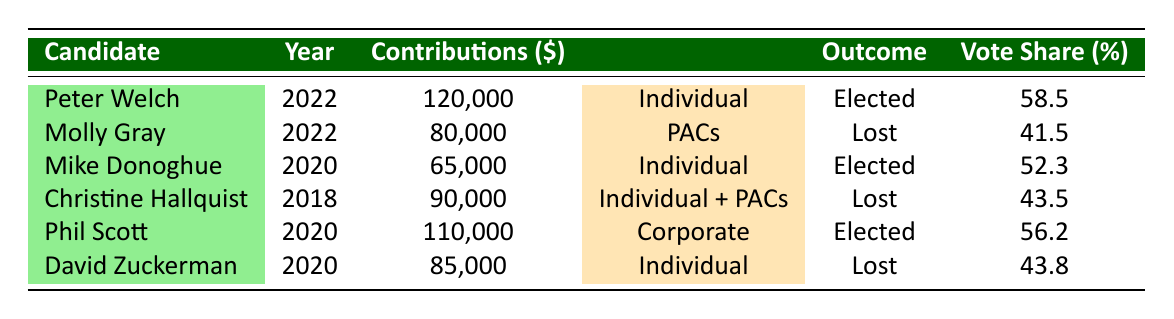What is the total contribution of Peter Welch in 2022? The table shows that Peter Welch received a total of 120,000 in contributions during the election year 2022.
Answer: 120000 Which candidate received the lowest total contributions? By comparing the total contributions across all candidates, Mike Donoghue received the lowest amount of 65,000 in 2020.
Answer: 65000 How many candidates were elected with contributions above 100,000? The candidates elected with contributions over 100,000 are Peter Welch (120,000) and Phil Scott (110,000). Thus, there are 2 candidates.
Answer: 2 What was the average vote share of the candidates who lost? The vote shares of the candidates who lost are 41.5 (Molly Gray) and 43.5 (Christine Hallquist) and 43.8 (David Zuckerman). The average is (41.5 + 43.5 + 43.8) / 3 = 42.6.
Answer: 42.6 Did any candidate lose with a higher vote share than David Zuckerman? David Zuckerman lost with a vote share of 43.8. The candidates who lost had vote shares of 41.5 and 43.5, which are both lower than 43.8. Therefore, the answer is no.
Answer: No What was the total contribution amount for candidates elected in 2020? The elected candidates in 2020 are Mike Donoghue (65,000) and Phil Scott (110,000). Their total contributions are 65,000 + 110,000 = 175,000.
Answer: 175000 Which funding source had the only candidate that lost in the 2022 election? The candidate who lost in the 2022 election is Molly Gray, who had contributions from Political Action Committees (PACs). So, the only funding source linked to a losing candidate in 2022 is PACs.
Answer: PACs Was the vote share of Christine Hallquist higher or lower than that of Mike Donoghue? Christine Hallquist had a vote share of 43.5, while Mike Donoghue had a vote share of 52.3. Since 43.5 is less than 52.3, Christine's vote share is lower.
Answer: Lower 